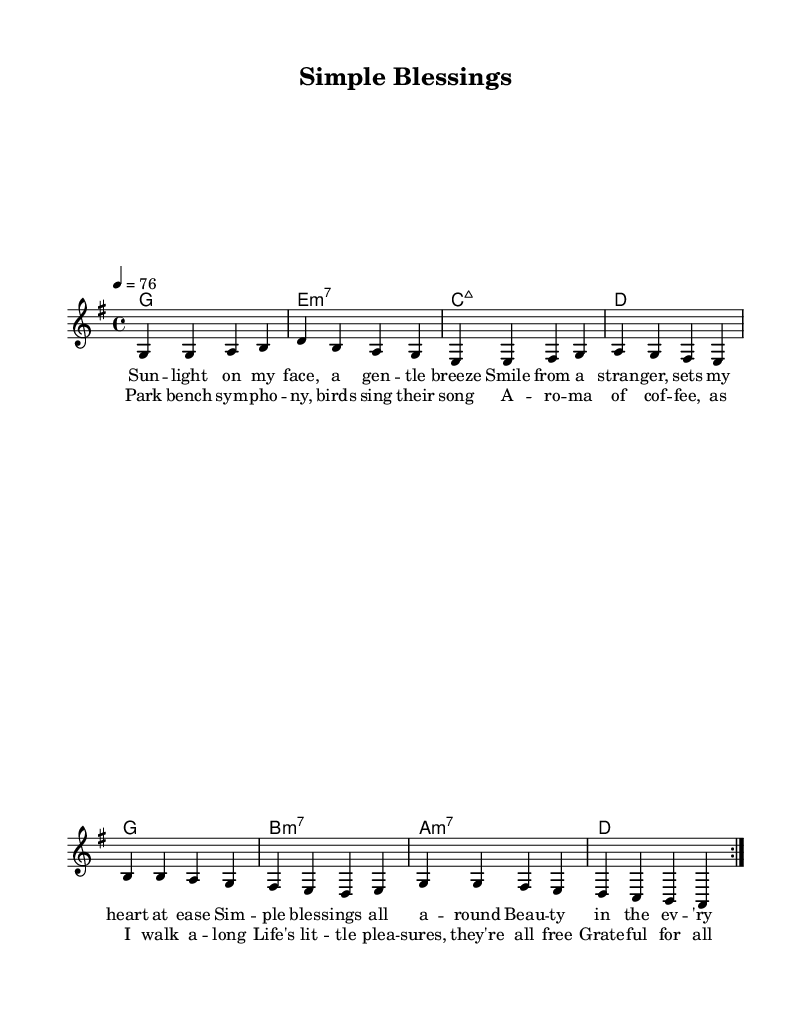What is the key signature of this music? The key signature is G major, which has one sharp (F#). This can be identified from the 'g' in the global settings indicating the key.
Answer: G major What is the time signature of this music? The time signature is 4/4, which means there are four beats in each measure. This is indicated in the global settings by '4/4' appearing after 'time'.
Answer: 4/4 What is the tempo of this music? The tempo is 76 beats per minute, which can be found in the global settings where 'tempo 4 = 76' is specified.
Answer: 76 How many verses are included in the lyrics? There are two verses included in the lyrics, as indicated by 'verseOne' and 'verseTwo' defined in the code. Each verse represents a section of the lyrics.
Answer: Two What is the primary theme of the lyrics? The primary theme of the lyrics is appreciating life's simple pleasures and finding beauty in everyday life. This can be derived from the content of both verses, which discuss moments of joy and gratitude in daily experiences.
Answer: Appreciation of simple pleasures Which chord is used in the first measure? The chord used in the first measure is G major, indicated in the harmonies section where 'g1' appears as the first chord.
Answer: G major What type of musical form does the piece follow based on the verses? The piece follows a verse-chorus structure, identifiable by the repetition of 'verseOne' and 'verseTwo', suggesting a basic arrangement where verses are traded or repeated, characteristic of soul music.
Answer: Verse-chorus structure 